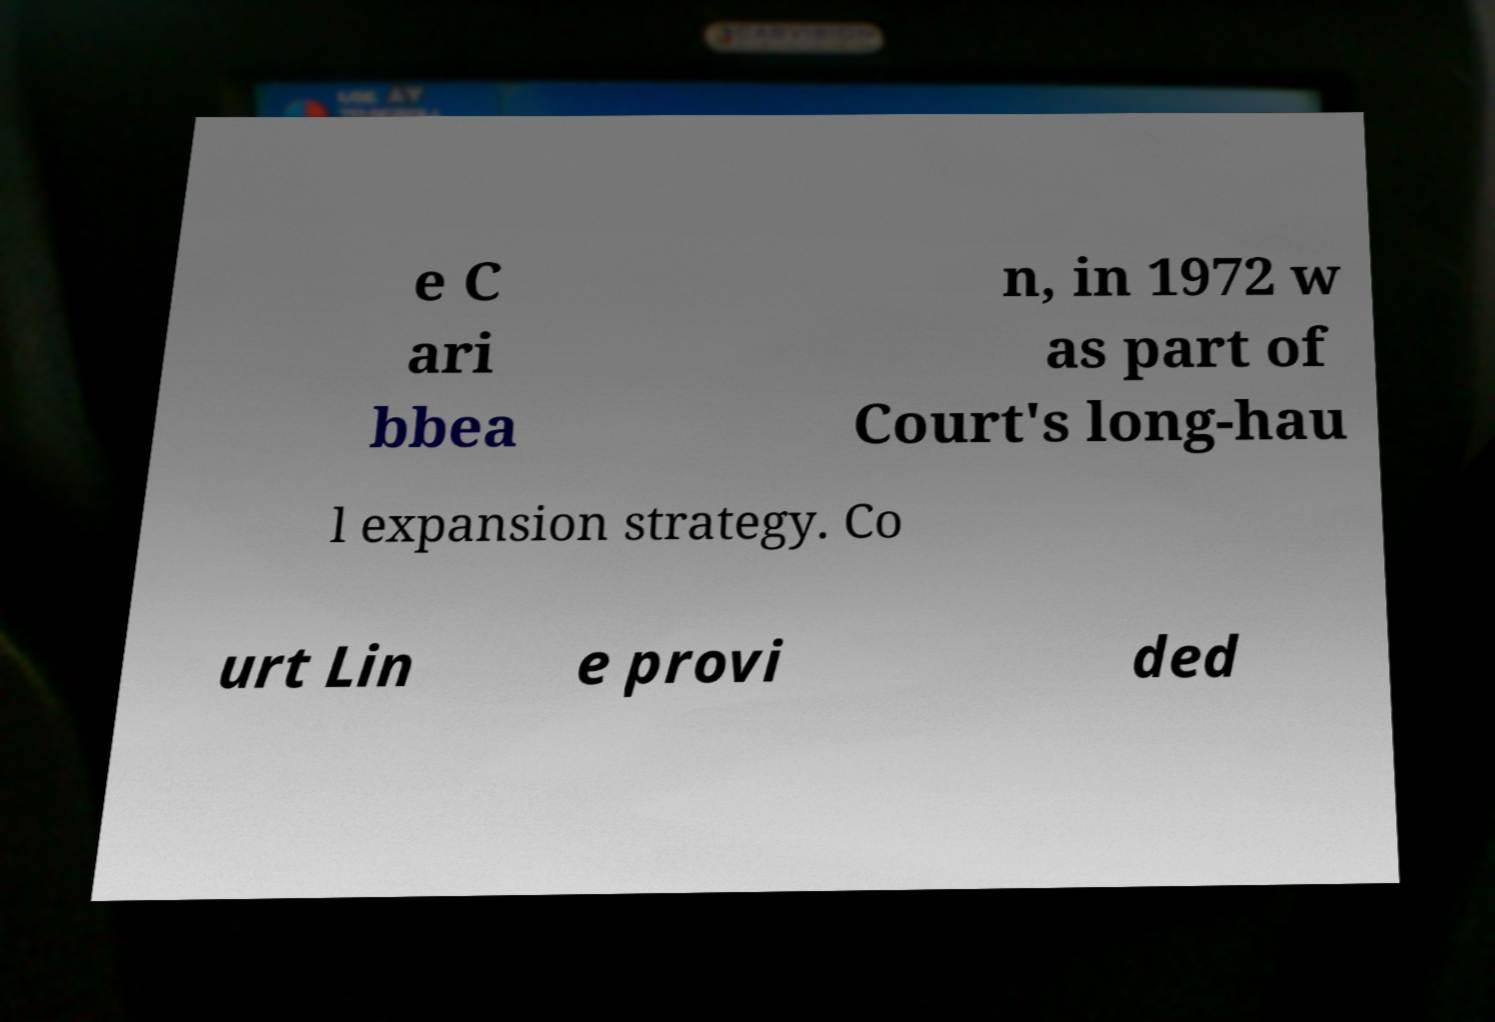Can you accurately transcribe the text from the provided image for me? e C ari bbea n, in 1972 w as part of Court's long-hau l expansion strategy. Co urt Lin e provi ded 